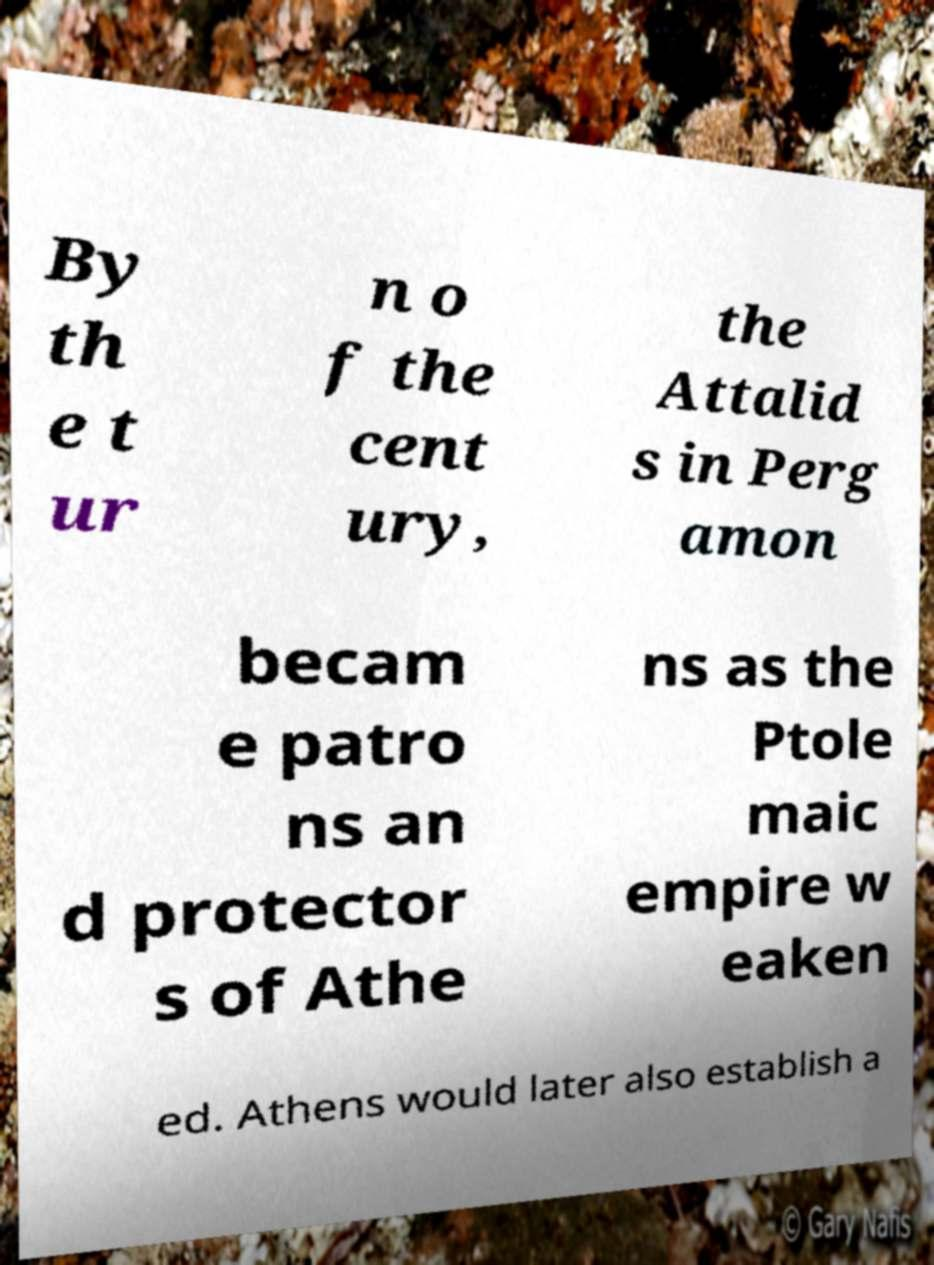Can you accurately transcribe the text from the provided image for me? By th e t ur n o f the cent ury, the Attalid s in Perg amon becam e patro ns an d protector s of Athe ns as the Ptole maic empire w eaken ed. Athens would later also establish a 